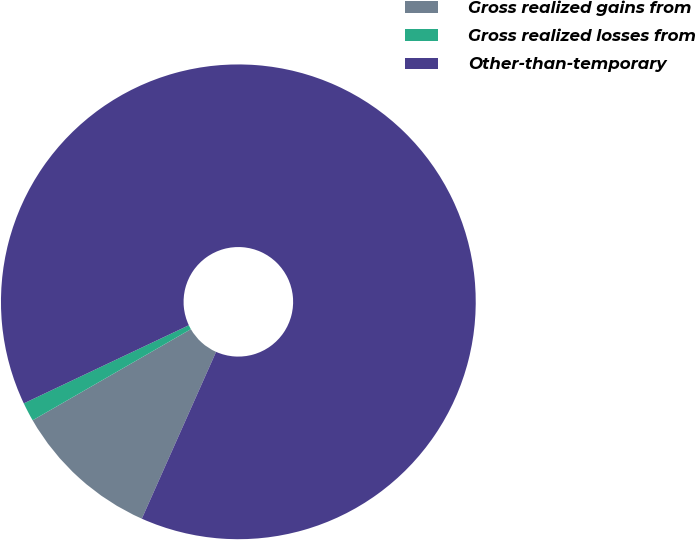Convert chart. <chart><loc_0><loc_0><loc_500><loc_500><pie_chart><fcel>Gross realized gains from<fcel>Gross realized losses from<fcel>Other-than-temporary<nl><fcel>10.02%<fcel>1.28%<fcel>88.7%<nl></chart> 